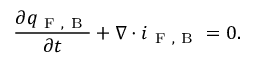Convert formula to latex. <formula><loc_0><loc_0><loc_500><loc_500>\frac { \partial q _ { F , B } } { \partial t } + \nabla \cdot i _ { F , B } = 0 .</formula> 